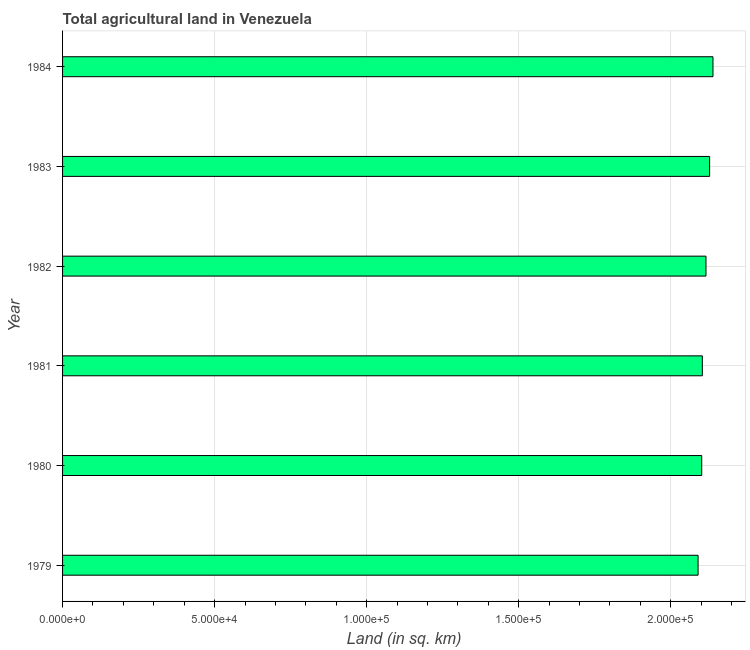Does the graph contain any zero values?
Your response must be concise. No. What is the title of the graph?
Your answer should be very brief. Total agricultural land in Venezuela. What is the label or title of the X-axis?
Your response must be concise. Land (in sq. km). What is the agricultural land in 1981?
Give a very brief answer. 2.10e+05. Across all years, what is the maximum agricultural land?
Make the answer very short. 2.14e+05. Across all years, what is the minimum agricultural land?
Make the answer very short. 2.09e+05. In which year was the agricultural land minimum?
Ensure brevity in your answer.  1979. What is the sum of the agricultural land?
Offer a terse response. 1.27e+06. What is the difference between the agricultural land in 1979 and 1983?
Offer a very short reply. -3800. What is the average agricultural land per year?
Your answer should be compact. 2.11e+05. What is the median agricultural land?
Offer a terse response. 2.11e+05. Is the agricultural land in 1980 less than that in 1983?
Ensure brevity in your answer.  Yes. What is the difference between the highest and the second highest agricultural land?
Your response must be concise. 1100. What is the difference between the highest and the lowest agricultural land?
Your answer should be very brief. 4900. How many bars are there?
Keep it short and to the point. 6. Are the values on the major ticks of X-axis written in scientific E-notation?
Ensure brevity in your answer.  Yes. What is the Land (in sq. km) of 1979?
Ensure brevity in your answer.  2.09e+05. What is the Land (in sq. km) in 1980?
Your response must be concise. 2.10e+05. What is the Land (in sq. km) of 1981?
Provide a short and direct response. 2.10e+05. What is the Land (in sq. km) of 1982?
Your answer should be compact. 2.12e+05. What is the Land (in sq. km) in 1983?
Provide a short and direct response. 2.13e+05. What is the Land (in sq. km) in 1984?
Offer a terse response. 2.14e+05. What is the difference between the Land (in sq. km) in 1979 and 1980?
Keep it short and to the point. -1200. What is the difference between the Land (in sq. km) in 1979 and 1981?
Offer a very short reply. -1400. What is the difference between the Land (in sq. km) in 1979 and 1982?
Give a very brief answer. -2600. What is the difference between the Land (in sq. km) in 1979 and 1983?
Keep it short and to the point. -3800. What is the difference between the Land (in sq. km) in 1979 and 1984?
Provide a succinct answer. -4900. What is the difference between the Land (in sq. km) in 1980 and 1981?
Give a very brief answer. -200. What is the difference between the Land (in sq. km) in 1980 and 1982?
Provide a succinct answer. -1400. What is the difference between the Land (in sq. km) in 1980 and 1983?
Give a very brief answer. -2600. What is the difference between the Land (in sq. km) in 1980 and 1984?
Offer a terse response. -3700. What is the difference between the Land (in sq. km) in 1981 and 1982?
Your answer should be compact. -1200. What is the difference between the Land (in sq. km) in 1981 and 1983?
Offer a very short reply. -2400. What is the difference between the Land (in sq. km) in 1981 and 1984?
Keep it short and to the point. -3500. What is the difference between the Land (in sq. km) in 1982 and 1983?
Your answer should be compact. -1200. What is the difference between the Land (in sq. km) in 1982 and 1984?
Keep it short and to the point. -2300. What is the difference between the Land (in sq. km) in 1983 and 1984?
Offer a very short reply. -1100. What is the ratio of the Land (in sq. km) in 1979 to that in 1981?
Keep it short and to the point. 0.99. What is the ratio of the Land (in sq. km) in 1979 to that in 1983?
Keep it short and to the point. 0.98. What is the ratio of the Land (in sq. km) in 1980 to that in 1981?
Make the answer very short. 1. What is the ratio of the Land (in sq. km) in 1980 to that in 1983?
Provide a succinct answer. 0.99. What is the ratio of the Land (in sq. km) in 1980 to that in 1984?
Provide a short and direct response. 0.98. What is the ratio of the Land (in sq. km) in 1981 to that in 1982?
Provide a succinct answer. 0.99. What is the ratio of the Land (in sq. km) in 1981 to that in 1984?
Offer a terse response. 0.98. What is the ratio of the Land (in sq. km) in 1983 to that in 1984?
Keep it short and to the point. 0.99. 